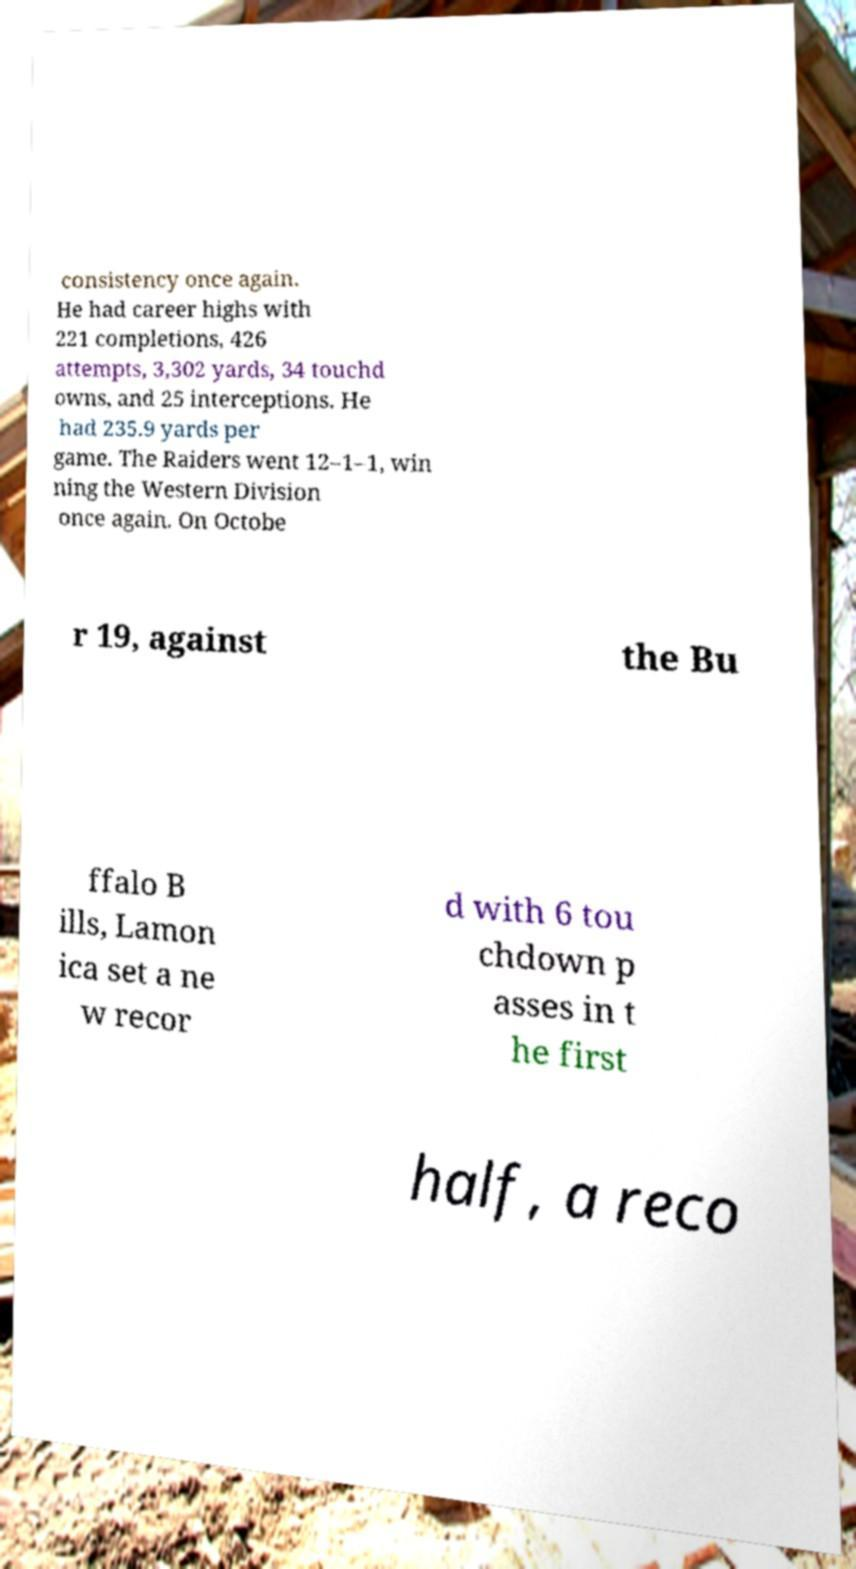Can you read and provide the text displayed in the image?This photo seems to have some interesting text. Can you extract and type it out for me? consistency once again. He had career highs with 221 completions, 426 attempts, 3,302 yards, 34 touchd owns, and 25 interceptions. He had 235.9 yards per game. The Raiders went 12–1–1, win ning the Western Division once again. On Octobe r 19, against the Bu ffalo B ills, Lamon ica set a ne w recor d with 6 tou chdown p asses in t he first half, a reco 